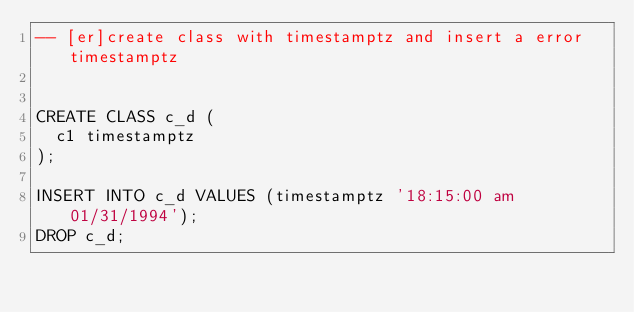Convert code to text. <code><loc_0><loc_0><loc_500><loc_500><_SQL_>-- [er]create class with timestamptz and insert a error timestamptz


CREATE CLASS c_d (
  c1 timestamptz
);

INSERT INTO c_d VALUES (timestamptz '18:15:00 am 01/31/1994');
DROP c_d;</code> 